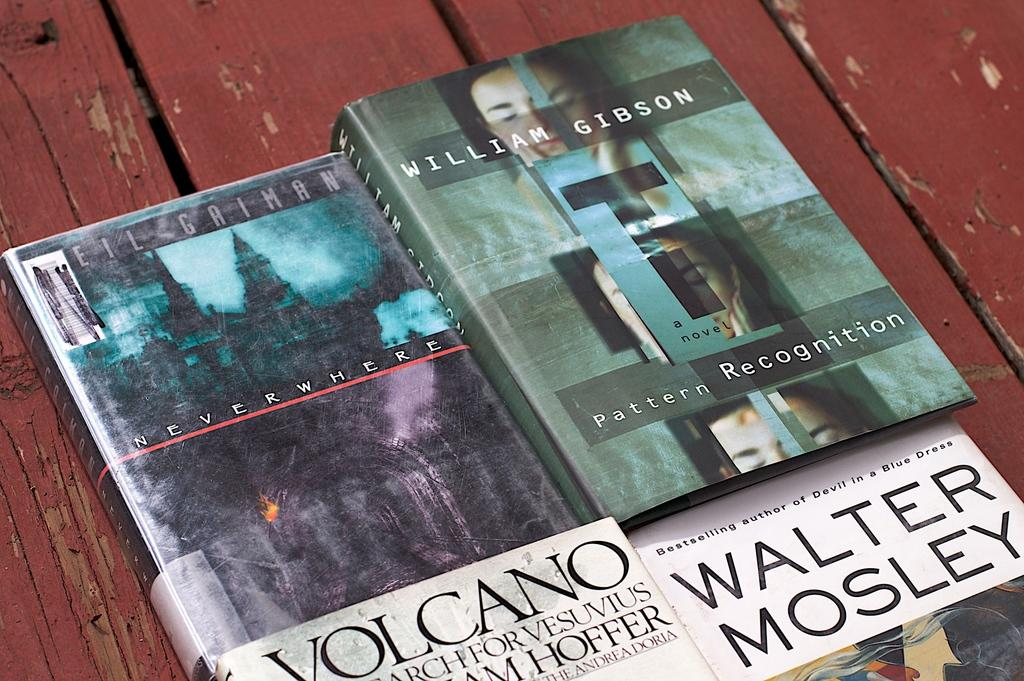<image>
Create a compact narrative representing the image presented. Book named "Neverwhere" next to a book by William Gibson. 